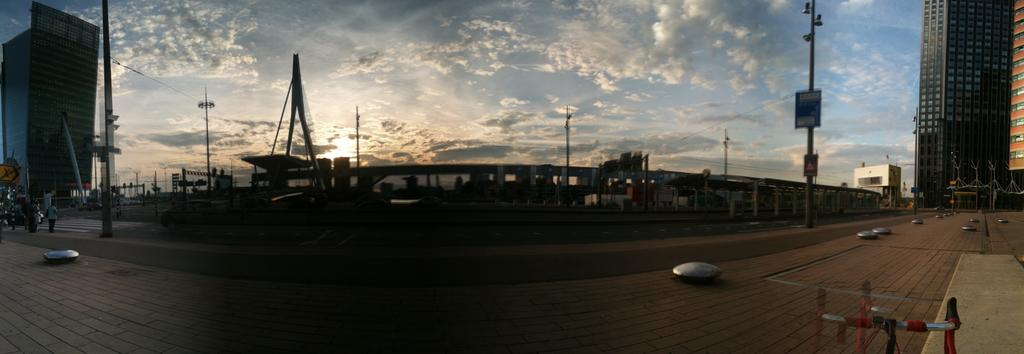What type of structures can be seen in the image? There are buildings in the image. What are the vertical objects in the image? There are poles in the image. What type of small shelter is present in the image? There is a shed in the image. What material is used for construction is visible in the image? There are boards in the image. What type of path is present in the image? There is a road in the image. What type of pedestrian path is present in the image? There is a walkway in the image. What objects are present in the image? There are objects in the image. Are there any people in the image? Yes, there are people in the image. What can be seen in the background of the image? The background of the image includes a cloudy sky. How many oranges are being held by the boy in the image? There is no boy or oranges present in the image. What type of bird can be seen perched on the wren in the image? There is no wren or bird present in the image. 